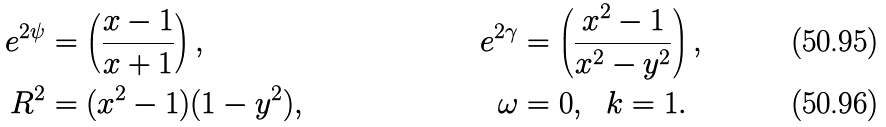<formula> <loc_0><loc_0><loc_500><loc_500>e ^ { 2 \psi } & = \left ( \frac { x - 1 } { x + 1 } \right ) , & e ^ { 2 \gamma } & = \left ( \frac { x ^ { 2 } - 1 } { x ^ { 2 } - y ^ { 2 } } \right ) , \\ R ^ { 2 } & = ( x ^ { 2 } - 1 ) ( 1 - y ^ { 2 } ) , & \omega & = 0 , \ \ k = 1 .</formula> 